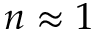<formula> <loc_0><loc_0><loc_500><loc_500>n \approx 1</formula> 